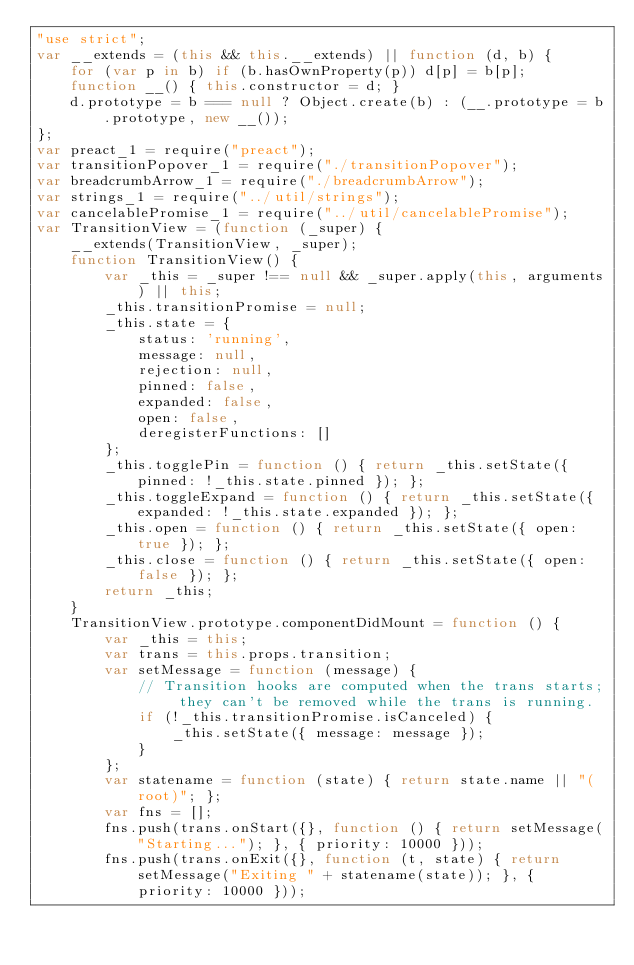Convert code to text. <code><loc_0><loc_0><loc_500><loc_500><_JavaScript_>"use strict";
var __extends = (this && this.__extends) || function (d, b) {
    for (var p in b) if (b.hasOwnProperty(p)) d[p] = b[p];
    function __() { this.constructor = d; }
    d.prototype = b === null ? Object.create(b) : (__.prototype = b.prototype, new __());
};
var preact_1 = require("preact");
var transitionPopover_1 = require("./transitionPopover");
var breadcrumbArrow_1 = require("./breadcrumbArrow");
var strings_1 = require("../util/strings");
var cancelablePromise_1 = require("../util/cancelablePromise");
var TransitionView = (function (_super) {
    __extends(TransitionView, _super);
    function TransitionView() {
        var _this = _super !== null && _super.apply(this, arguments) || this;
        _this.transitionPromise = null;
        _this.state = {
            status: 'running',
            message: null,
            rejection: null,
            pinned: false,
            expanded: false,
            open: false,
            deregisterFunctions: []
        };
        _this.togglePin = function () { return _this.setState({ pinned: !_this.state.pinned }); };
        _this.toggleExpand = function () { return _this.setState({ expanded: !_this.state.expanded }); };
        _this.open = function () { return _this.setState({ open: true }); };
        _this.close = function () { return _this.setState({ open: false }); };
        return _this;
    }
    TransitionView.prototype.componentDidMount = function () {
        var _this = this;
        var trans = this.props.transition;
        var setMessage = function (message) {
            // Transition hooks are computed when the trans starts; they can't be removed while the trans is running.
            if (!_this.transitionPromise.isCanceled) {
                _this.setState({ message: message });
            }
        };
        var statename = function (state) { return state.name || "(root)"; };
        var fns = [];
        fns.push(trans.onStart({}, function () { return setMessage("Starting..."); }, { priority: 10000 }));
        fns.push(trans.onExit({}, function (t, state) { return setMessage("Exiting " + statename(state)); }, { priority: 10000 }));</code> 